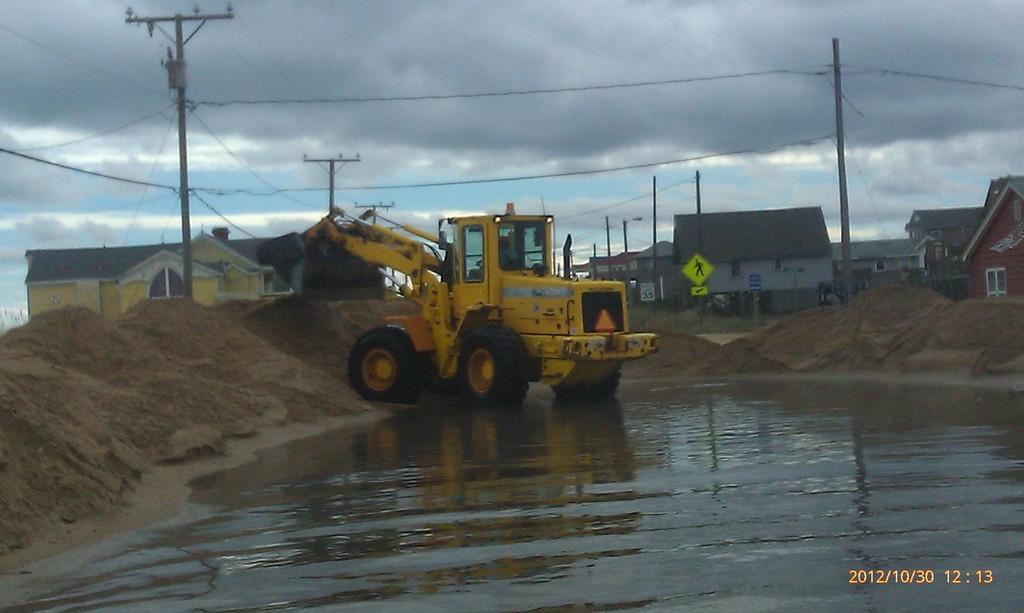What date was the picture taken?
Your response must be concise. 2012/10/30. What is the date of this picture?
Your answer should be very brief. 2012/10/30. 